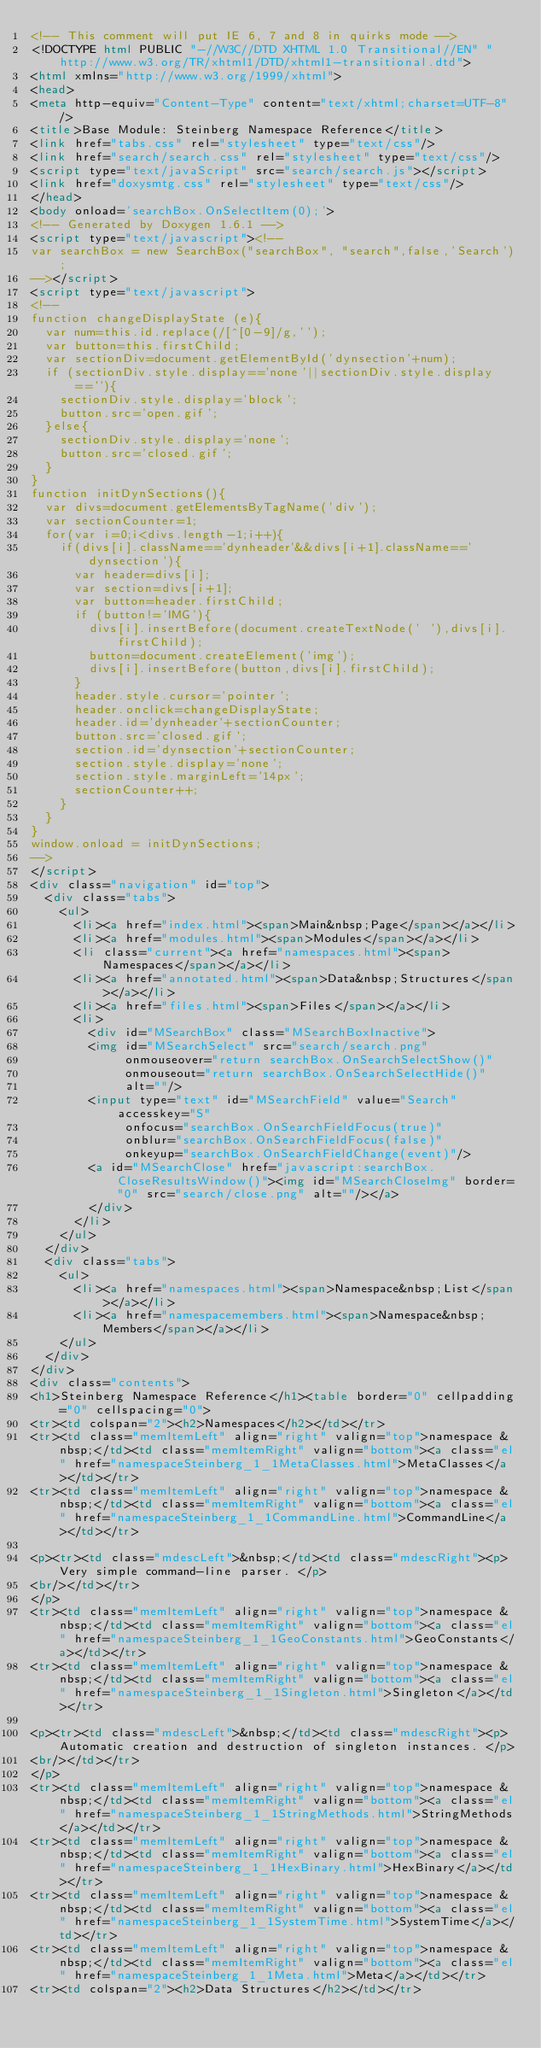Convert code to text. <code><loc_0><loc_0><loc_500><loc_500><_HTML_><!-- This comment will put IE 6, 7 and 8 in quirks mode -->
<!DOCTYPE html PUBLIC "-//W3C//DTD XHTML 1.0 Transitional//EN" "http://www.w3.org/TR/xhtml1/DTD/xhtml1-transitional.dtd">
<html xmlns="http://www.w3.org/1999/xhtml">
<head>
<meta http-equiv="Content-Type" content="text/xhtml;charset=UTF-8"/>
<title>Base Module: Steinberg Namespace Reference</title>
<link href="tabs.css" rel="stylesheet" type="text/css"/>
<link href="search/search.css" rel="stylesheet" type="text/css"/>
<script type="text/javaScript" src="search/search.js"></script>
<link href="doxysmtg.css" rel="stylesheet" type="text/css"/>
</head>
<body onload='searchBox.OnSelectItem(0);'>
<!-- Generated by Doxygen 1.6.1 -->
<script type="text/javascript"><!--
var searchBox = new SearchBox("searchBox", "search",false,'Search');
--></script>
<script type="text/javascript">
<!--
function changeDisplayState (e){
  var num=this.id.replace(/[^[0-9]/g,'');
  var button=this.firstChild;
  var sectionDiv=document.getElementById('dynsection'+num);
  if (sectionDiv.style.display=='none'||sectionDiv.style.display==''){
    sectionDiv.style.display='block';
    button.src='open.gif';
  }else{
    sectionDiv.style.display='none';
    button.src='closed.gif';
  }
}
function initDynSections(){
  var divs=document.getElementsByTagName('div');
  var sectionCounter=1;
  for(var i=0;i<divs.length-1;i++){
    if(divs[i].className=='dynheader'&&divs[i+1].className=='dynsection'){
      var header=divs[i];
      var section=divs[i+1];
      var button=header.firstChild;
      if (button!='IMG'){
        divs[i].insertBefore(document.createTextNode(' '),divs[i].firstChild);
        button=document.createElement('img');
        divs[i].insertBefore(button,divs[i].firstChild);
      }
      header.style.cursor='pointer';
      header.onclick=changeDisplayState;
      header.id='dynheader'+sectionCounter;
      button.src='closed.gif';
      section.id='dynsection'+sectionCounter;
      section.style.display='none';
      section.style.marginLeft='14px';
      sectionCounter++;
    }
  }
}
window.onload = initDynSections;
-->
</script>
<div class="navigation" id="top">
  <div class="tabs">
    <ul>
      <li><a href="index.html"><span>Main&nbsp;Page</span></a></li>
      <li><a href="modules.html"><span>Modules</span></a></li>
      <li class="current"><a href="namespaces.html"><span>Namespaces</span></a></li>
      <li><a href="annotated.html"><span>Data&nbsp;Structures</span></a></li>
      <li><a href="files.html"><span>Files</span></a></li>
      <li>
        <div id="MSearchBox" class="MSearchBoxInactive">
        <img id="MSearchSelect" src="search/search.png"
             onmouseover="return searchBox.OnSearchSelectShow()"
             onmouseout="return searchBox.OnSearchSelectHide()"
             alt=""/>
        <input type="text" id="MSearchField" value="Search" accesskey="S"
             onfocus="searchBox.OnSearchFieldFocus(true)" 
             onblur="searchBox.OnSearchFieldFocus(false)" 
             onkeyup="searchBox.OnSearchFieldChange(event)"/>
        <a id="MSearchClose" href="javascript:searchBox.CloseResultsWindow()"><img id="MSearchCloseImg" border="0" src="search/close.png" alt=""/></a>
        </div>
      </li>
    </ul>
  </div>
  <div class="tabs">
    <ul>
      <li><a href="namespaces.html"><span>Namespace&nbsp;List</span></a></li>
      <li><a href="namespacemembers.html"><span>Namespace&nbsp;Members</span></a></li>
    </ul>
  </div>
</div>
<div class="contents">
<h1>Steinberg Namespace Reference</h1><table border="0" cellpadding="0" cellspacing="0">
<tr><td colspan="2"><h2>Namespaces</h2></td></tr>
<tr><td class="memItemLeft" align="right" valign="top">namespace &nbsp;</td><td class="memItemRight" valign="bottom"><a class="el" href="namespaceSteinberg_1_1MetaClasses.html">MetaClasses</a></td></tr>
<tr><td class="memItemLeft" align="right" valign="top">namespace &nbsp;</td><td class="memItemRight" valign="bottom"><a class="el" href="namespaceSteinberg_1_1CommandLine.html">CommandLine</a></td></tr>

<p><tr><td class="mdescLeft">&nbsp;</td><td class="mdescRight"><p>Very simple command-line parser. </p>
<br/></td></tr>
</p>
<tr><td class="memItemLeft" align="right" valign="top">namespace &nbsp;</td><td class="memItemRight" valign="bottom"><a class="el" href="namespaceSteinberg_1_1GeoConstants.html">GeoConstants</a></td></tr>
<tr><td class="memItemLeft" align="right" valign="top">namespace &nbsp;</td><td class="memItemRight" valign="bottom"><a class="el" href="namespaceSteinberg_1_1Singleton.html">Singleton</a></td></tr>

<p><tr><td class="mdescLeft">&nbsp;</td><td class="mdescRight"><p>Automatic creation and destruction of singleton instances. </p>
<br/></td></tr>
</p>
<tr><td class="memItemLeft" align="right" valign="top">namespace &nbsp;</td><td class="memItemRight" valign="bottom"><a class="el" href="namespaceSteinberg_1_1StringMethods.html">StringMethods</a></td></tr>
<tr><td class="memItemLeft" align="right" valign="top">namespace &nbsp;</td><td class="memItemRight" valign="bottom"><a class="el" href="namespaceSteinberg_1_1HexBinary.html">HexBinary</a></td></tr>
<tr><td class="memItemLeft" align="right" valign="top">namespace &nbsp;</td><td class="memItemRight" valign="bottom"><a class="el" href="namespaceSteinberg_1_1SystemTime.html">SystemTime</a></td></tr>
<tr><td class="memItemLeft" align="right" valign="top">namespace &nbsp;</td><td class="memItemRight" valign="bottom"><a class="el" href="namespaceSteinberg_1_1Meta.html">Meta</a></td></tr>
<tr><td colspan="2"><h2>Data Structures</h2></td></tr></code> 